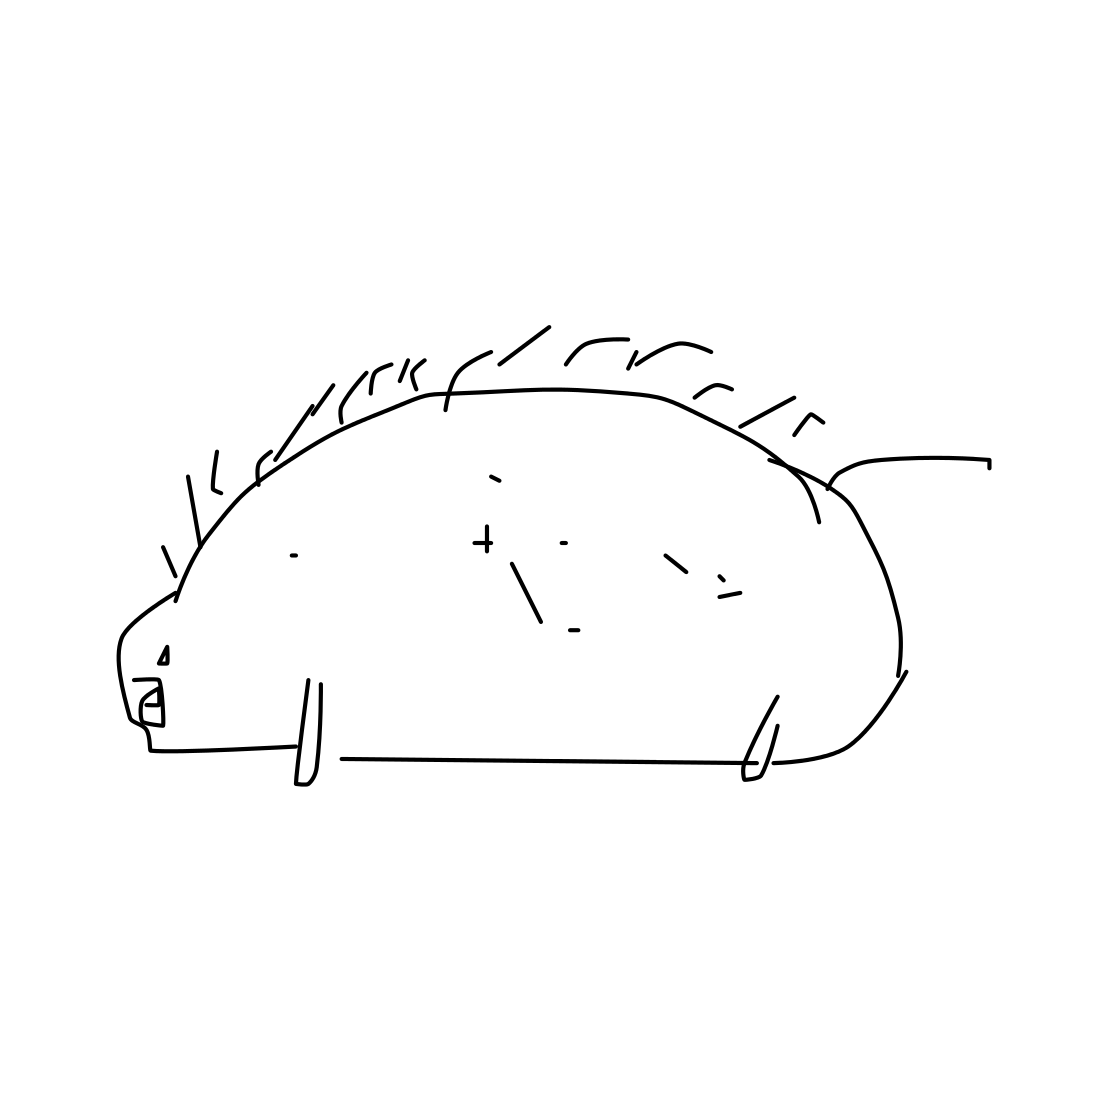Is there a sketchy hedgehog in the picture? Yes, the picture features a whimsically drawn, sketchy hedgehog. This simple line drawing captures the essence of a hedgehog with subtle spikes and a basic outline of its shape. 